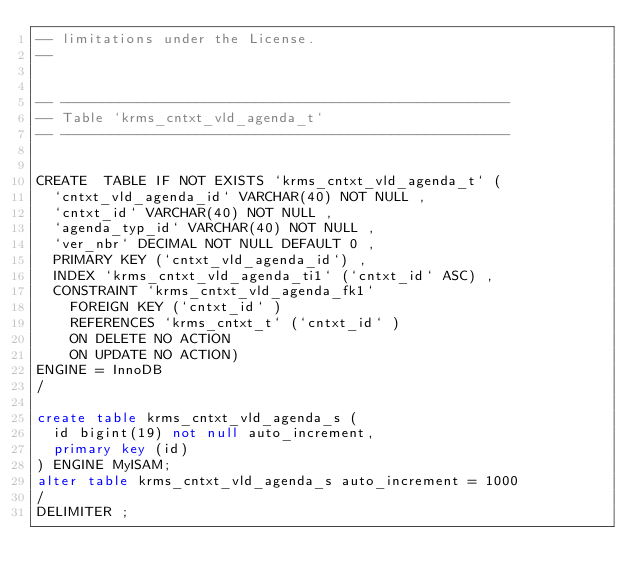Convert code to text. <code><loc_0><loc_0><loc_500><loc_500><_SQL_>-- limitations under the License.
--


-- -----------------------------------------------------
-- Table `krms_cntxt_vld_agenda_t`
-- -----------------------------------------------------


CREATE  TABLE IF NOT EXISTS `krms_cntxt_vld_agenda_t` (
  `cntxt_vld_agenda_id` VARCHAR(40) NOT NULL ,
  `cntxt_id` VARCHAR(40) NOT NULL ,
  `agenda_typ_id` VARCHAR(40) NOT NULL ,
  `ver_nbr` DECIMAL NOT NULL DEFAULT 0 ,
  PRIMARY KEY (`cntxt_vld_agenda_id`) ,
  INDEX `krms_cntxt_vld_agenda_ti1` (`cntxt_id` ASC) ,
  CONSTRAINT `krms_cntxt_vld_agenda_fk1`
    FOREIGN KEY (`cntxt_id` )
    REFERENCES `krms_cntxt_t` (`cntxt_id` )
    ON DELETE NO ACTION
    ON UPDATE NO ACTION)
ENGINE = InnoDB
/

create table krms_cntxt_vld_agenda_s ( 
  id bigint(19) not null auto_increment, 
  primary key (id) 
) ENGINE MyISAM; 
alter table krms_cntxt_vld_agenda_s auto_increment = 1000
/
DELIMITER ;
</code> 